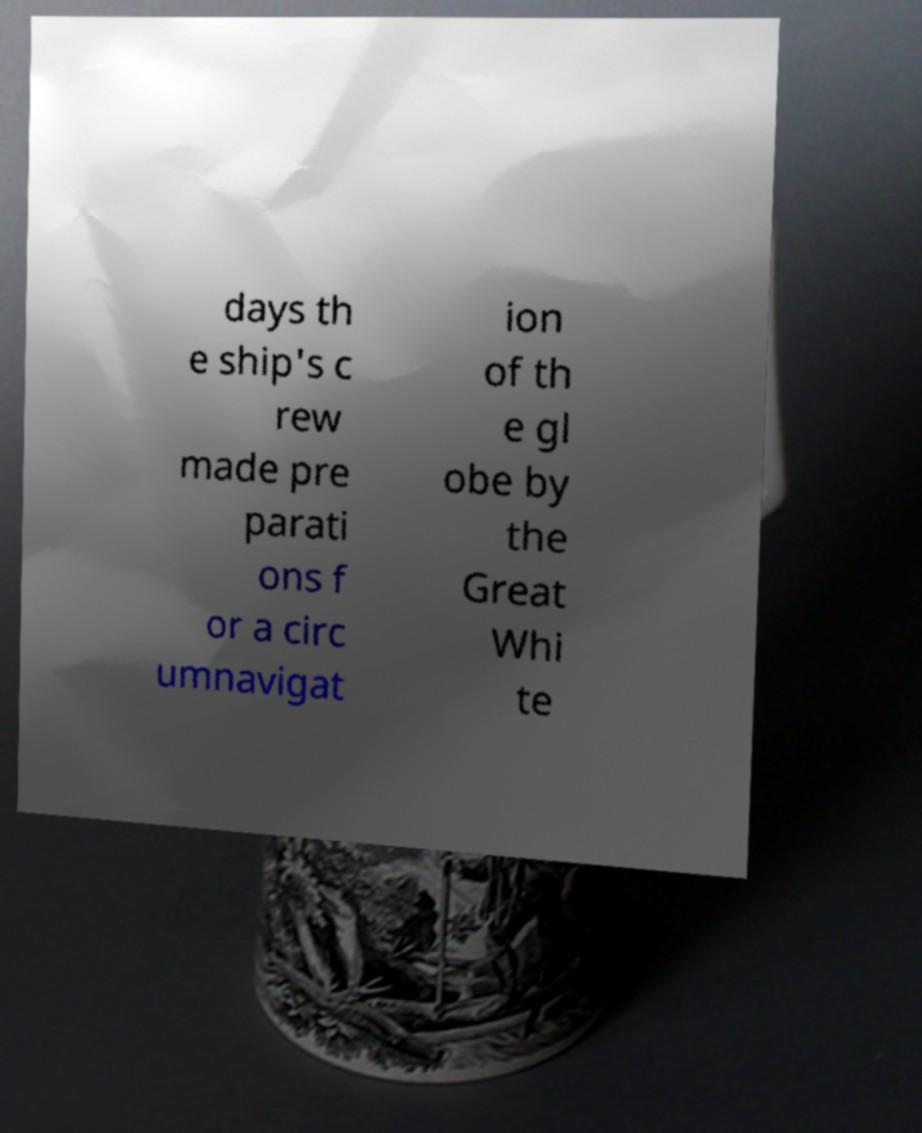Could you assist in decoding the text presented in this image and type it out clearly? days th e ship's c rew made pre parati ons f or a circ umnavigat ion of th e gl obe by the Great Whi te 